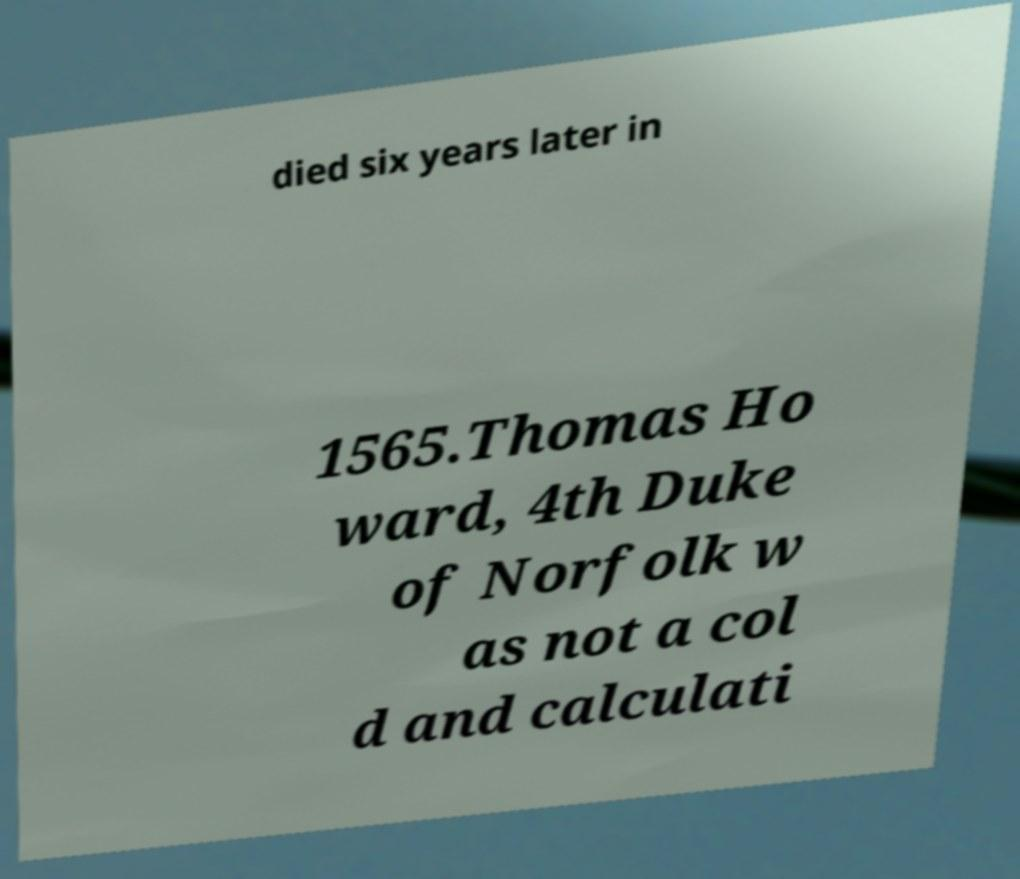Could you assist in decoding the text presented in this image and type it out clearly? died six years later in 1565.Thomas Ho ward, 4th Duke of Norfolk w as not a col d and calculati 